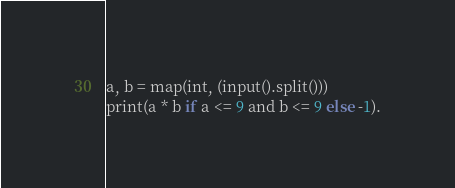<code> <loc_0><loc_0><loc_500><loc_500><_Python_>a, b = map(int, (input().split()))
print(a * b if a <= 9 and b <= 9 else -1).</code> 